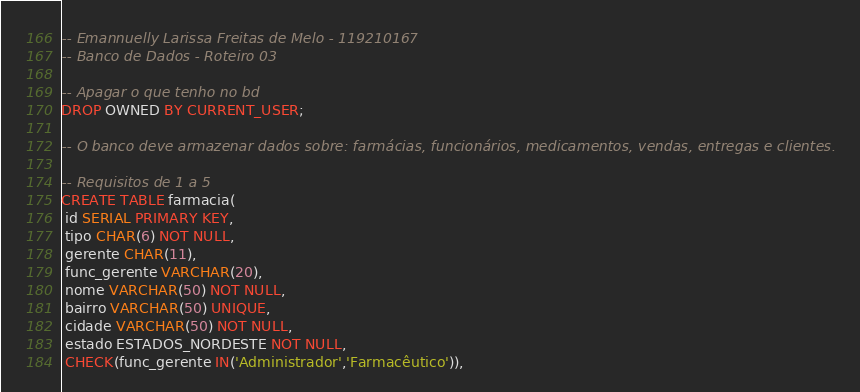Convert code to text. <code><loc_0><loc_0><loc_500><loc_500><_SQL_>-- Emannuelly Larissa Freitas de Melo - 119210167
-- Banco de Dados - Roteiro 03

-- Apagar o que tenho no bd
DROP OWNED BY CURRENT_USER;

-- O banco deve armazenar dados sobre: farmácias, funcionários, medicamentos, vendas, entregas e clientes.

-- Requisitos de 1 a 5 
CREATE TABLE farmacia(
 id SERIAL PRIMARY KEY,
 tipo CHAR(6) NOT NULL,
 gerente CHAR(11),
 func_gerente VARCHAR(20),
 nome VARCHAR(50) NOT NULL,
 bairro VARCHAR(50) UNIQUE,
 cidade VARCHAR(50) NOT NULL,
 estado ESTADOS_NORDESTE NOT NULL,
 CHECK(func_gerente IN('Administrador','Farmacêutico')),</code> 